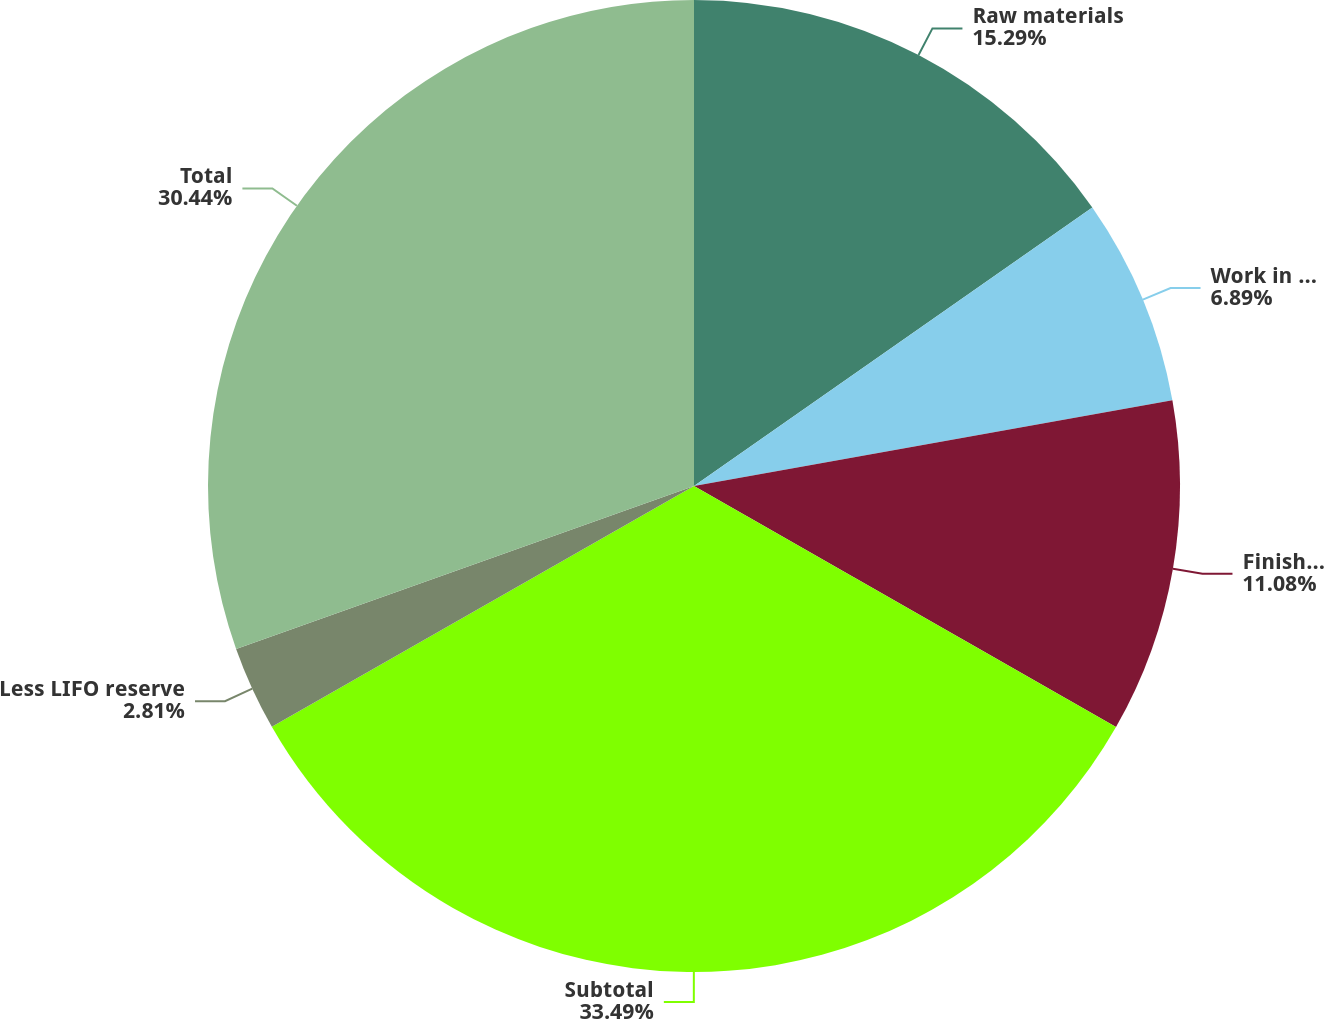<chart> <loc_0><loc_0><loc_500><loc_500><pie_chart><fcel>Raw materials<fcel>Work in progress<fcel>Finished goods<fcel>Subtotal<fcel>Less LIFO reserve<fcel>Total<nl><fcel>15.29%<fcel>6.89%<fcel>11.08%<fcel>33.49%<fcel>2.81%<fcel>30.44%<nl></chart> 